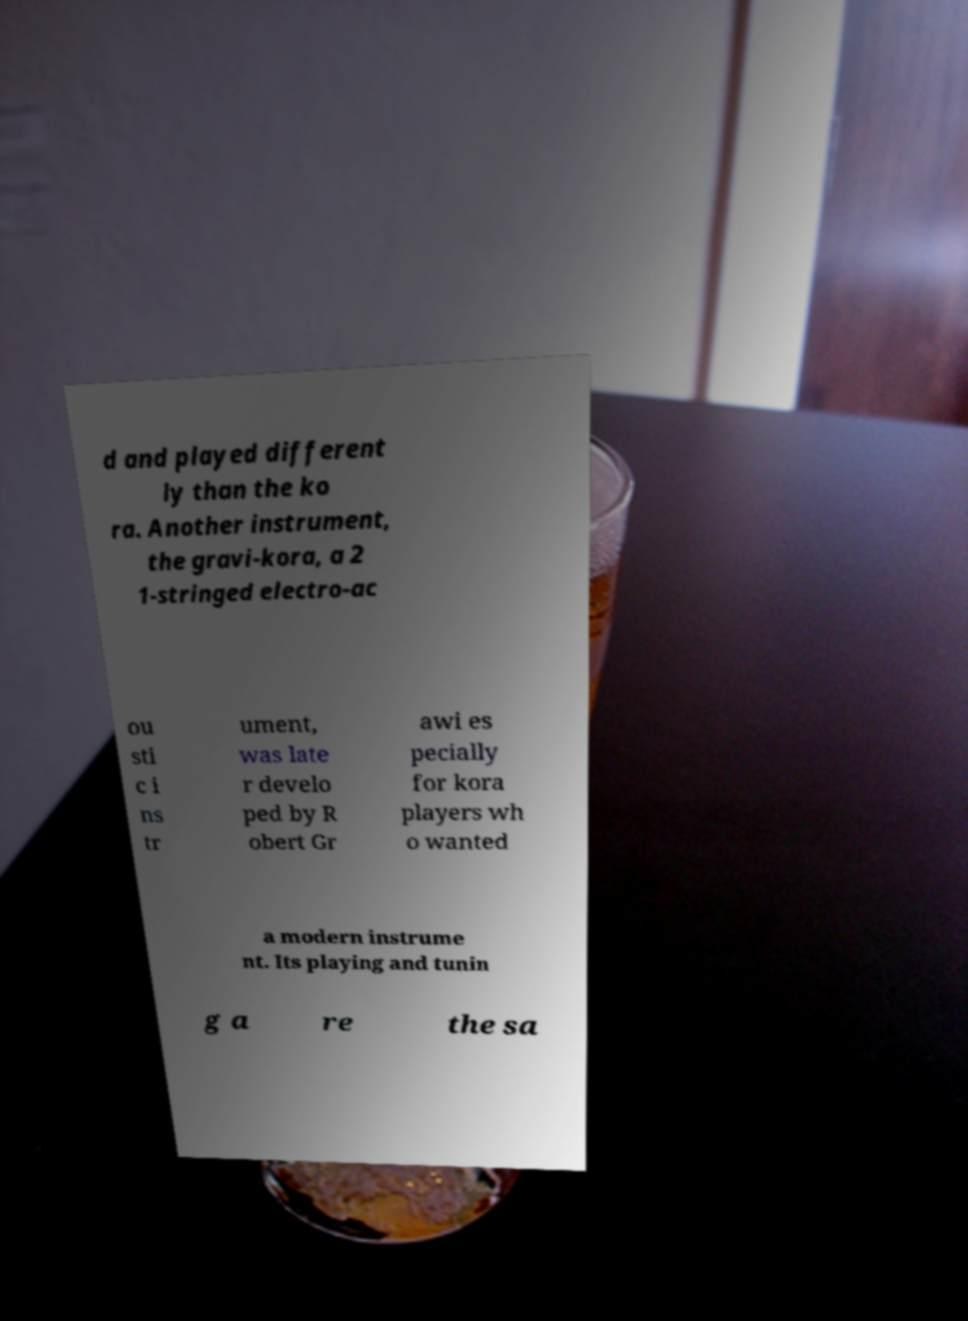Please identify and transcribe the text found in this image. d and played different ly than the ko ra. Another instrument, the gravi-kora, a 2 1-stringed electro-ac ou sti c i ns tr ument, was late r develo ped by R obert Gr awi es pecially for kora players wh o wanted a modern instrume nt. Its playing and tunin g a re the sa 